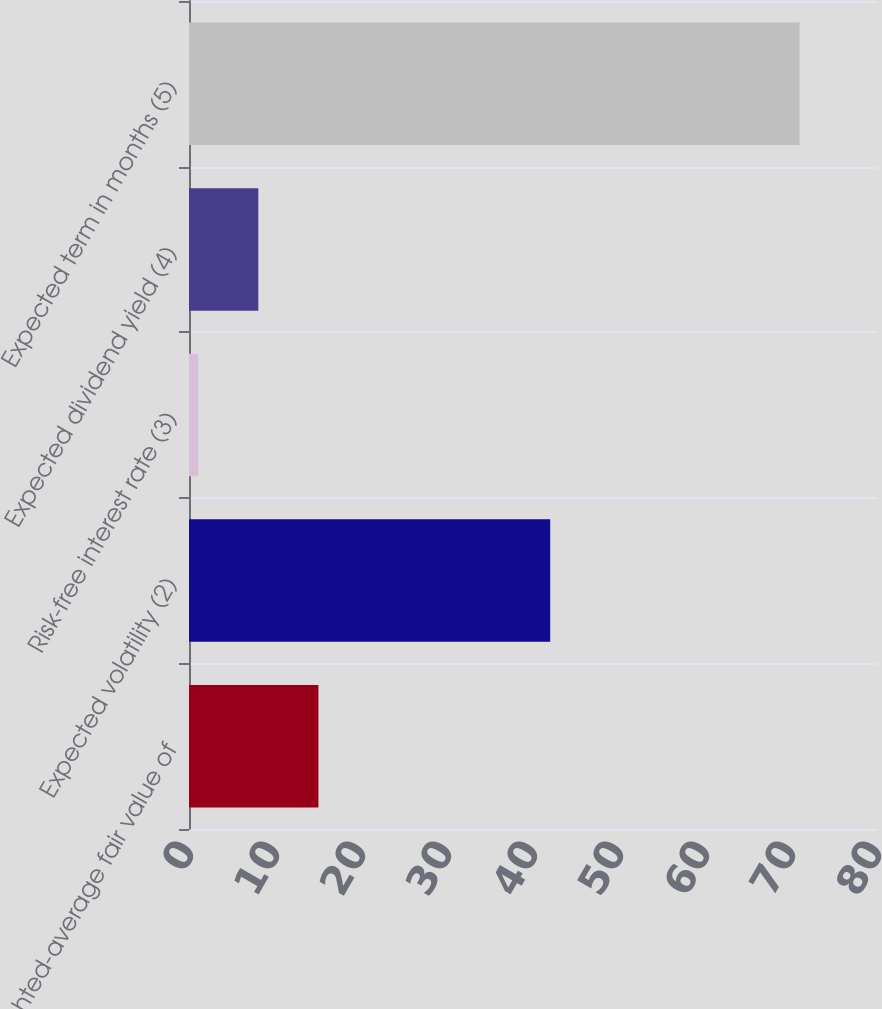Convert chart. <chart><loc_0><loc_0><loc_500><loc_500><bar_chart><fcel>Weighted-average fair value of<fcel>Expected volatility (2)<fcel>Risk-free interest rate (3)<fcel>Expected dividend yield (4)<fcel>Expected term in months (5)<nl><fcel>15.05<fcel>42<fcel>1.07<fcel>8.06<fcel>71<nl></chart> 